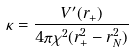<formula> <loc_0><loc_0><loc_500><loc_500>\kappa = \frac { V ^ { \prime } ( r _ { + } ) } { 4 \pi \chi ^ { 2 } ( r _ { + } ^ { 2 } - r _ { N } ^ { 2 } ) }</formula> 